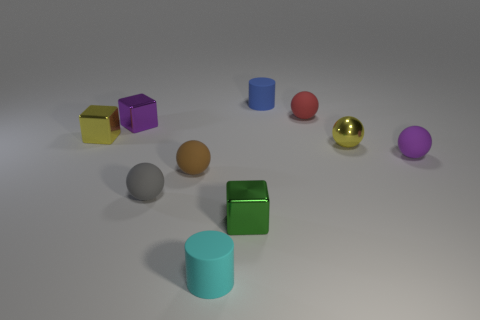Subtract all gray spheres. How many spheres are left? 4 Subtract all purple balls. How many balls are left? 4 Subtract all cyan spheres. Subtract all gray cylinders. How many spheres are left? 5 Subtract all cylinders. How many objects are left? 8 Subtract all brown rubber balls. Subtract all rubber balls. How many objects are left? 5 Add 5 red balls. How many red balls are left? 6 Add 3 blue cylinders. How many blue cylinders exist? 4 Subtract 1 cyan cylinders. How many objects are left? 9 